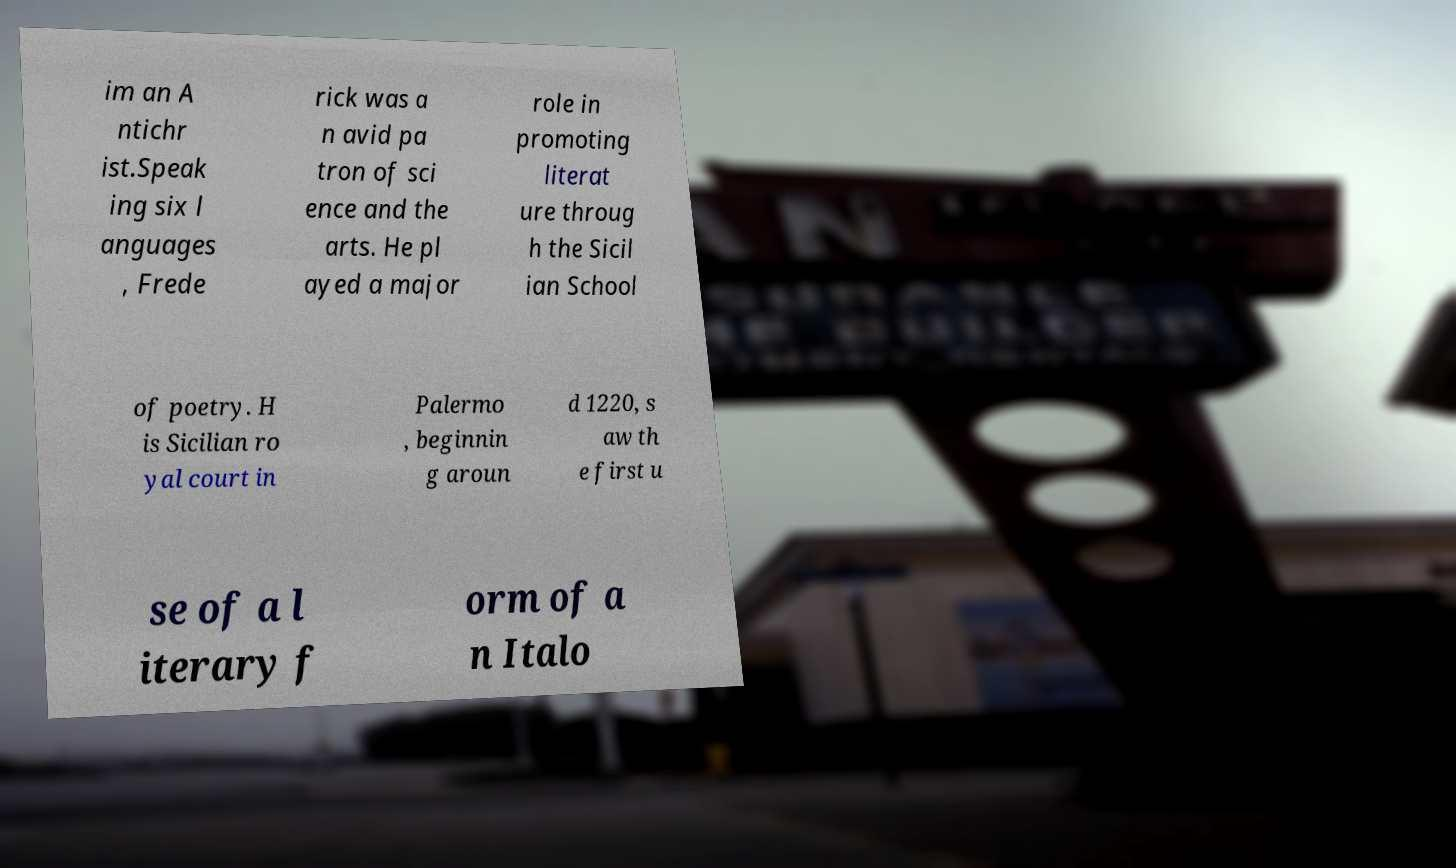Can you read and provide the text displayed in the image?This photo seems to have some interesting text. Can you extract and type it out for me? im an A ntichr ist.Speak ing six l anguages , Frede rick was a n avid pa tron of sci ence and the arts. He pl ayed a major role in promoting literat ure throug h the Sicil ian School of poetry. H is Sicilian ro yal court in Palermo , beginnin g aroun d 1220, s aw th e first u se of a l iterary f orm of a n Italo 